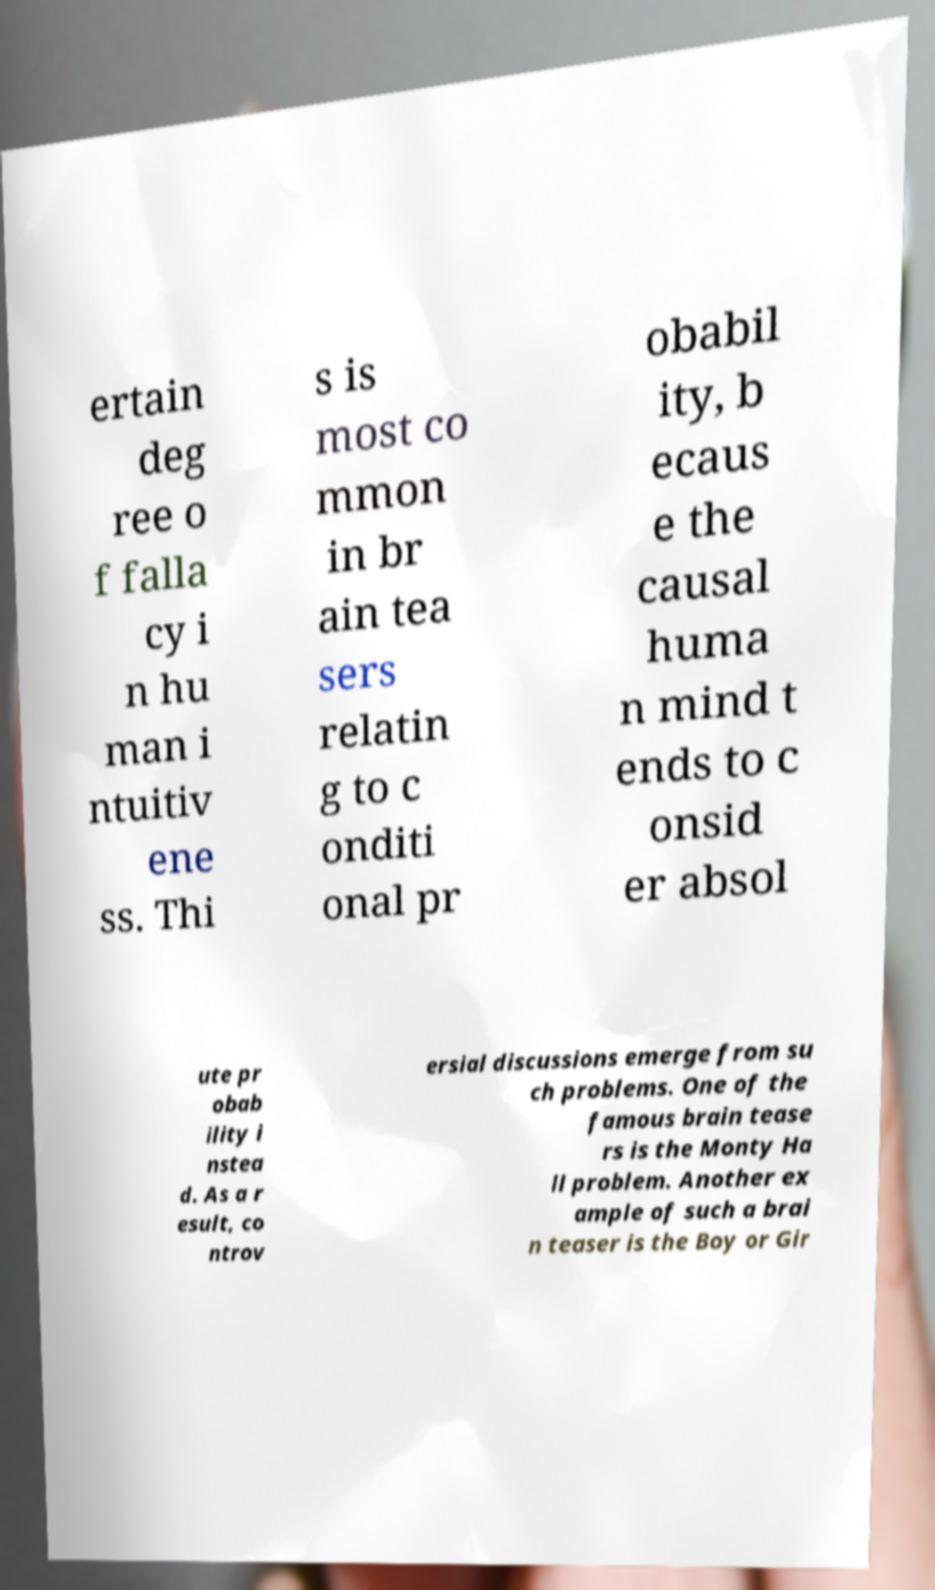I need the written content from this picture converted into text. Can you do that? ertain deg ree o f falla cy i n hu man i ntuitiv ene ss. Thi s is most co mmon in br ain tea sers relatin g to c onditi onal pr obabil ity, b ecaus e the causal huma n mind t ends to c onsid er absol ute pr obab ility i nstea d. As a r esult, co ntrov ersial discussions emerge from su ch problems. One of the famous brain tease rs is the Monty Ha ll problem. Another ex ample of such a brai n teaser is the Boy or Gir 